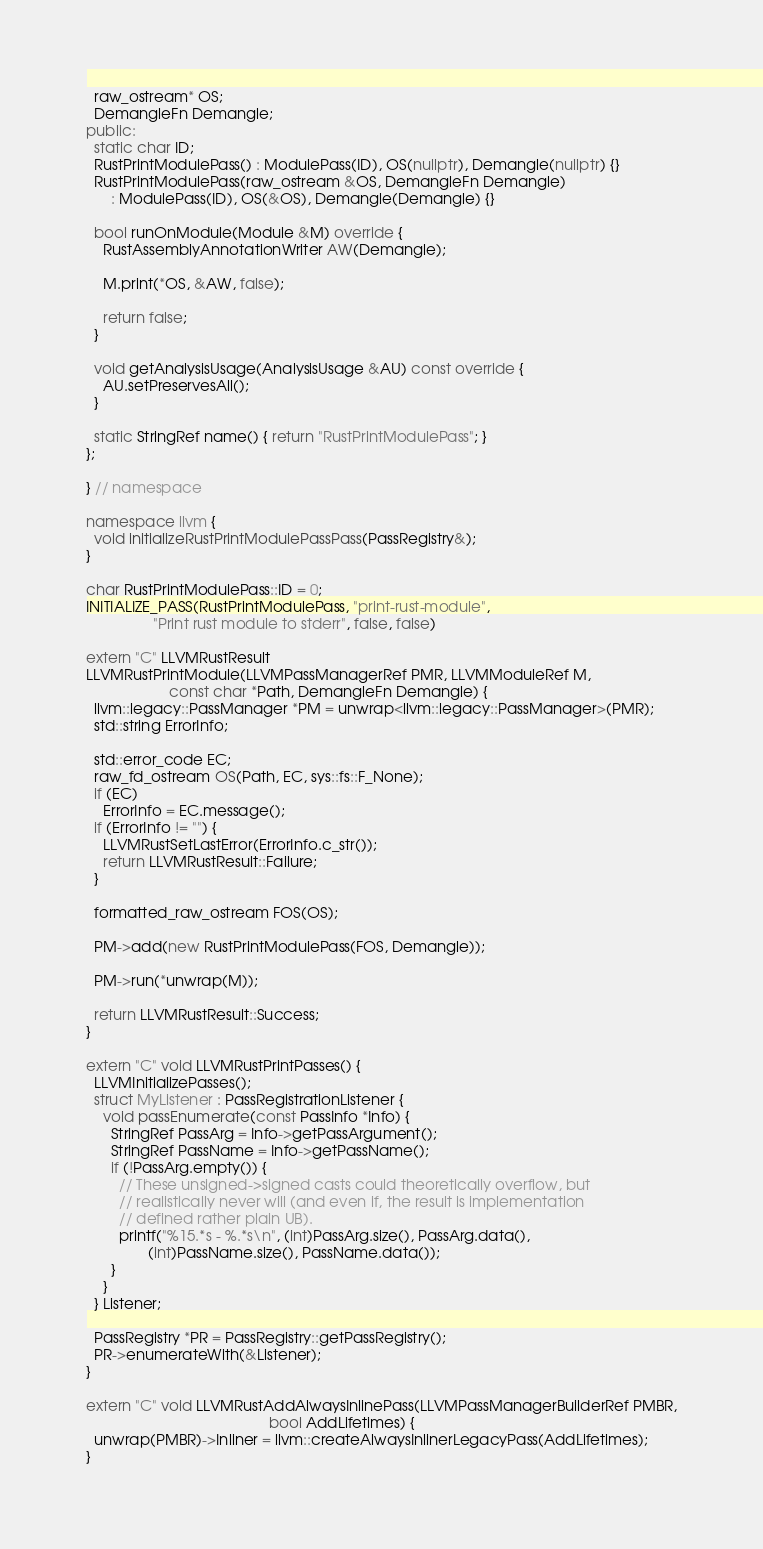Convert code to text. <code><loc_0><loc_0><loc_500><loc_500><_C++_>  raw_ostream* OS;
  DemangleFn Demangle;
public:
  static char ID;
  RustPrintModulePass() : ModulePass(ID), OS(nullptr), Demangle(nullptr) {}
  RustPrintModulePass(raw_ostream &OS, DemangleFn Demangle)
      : ModulePass(ID), OS(&OS), Demangle(Demangle) {}

  bool runOnModule(Module &M) override {
    RustAssemblyAnnotationWriter AW(Demangle);

    M.print(*OS, &AW, false);

    return false;
  }

  void getAnalysisUsage(AnalysisUsage &AU) const override {
    AU.setPreservesAll();
  }

  static StringRef name() { return "RustPrintModulePass"; }
};

} // namespace

namespace llvm {
  void initializeRustPrintModulePassPass(PassRegistry&);
}

char RustPrintModulePass::ID = 0;
INITIALIZE_PASS(RustPrintModulePass, "print-rust-module",
                "Print rust module to stderr", false, false)

extern "C" LLVMRustResult
LLVMRustPrintModule(LLVMPassManagerRef PMR, LLVMModuleRef M,
                    const char *Path, DemangleFn Demangle) {
  llvm::legacy::PassManager *PM = unwrap<llvm::legacy::PassManager>(PMR);
  std::string ErrorInfo;

  std::error_code EC;
  raw_fd_ostream OS(Path, EC, sys::fs::F_None);
  if (EC)
    ErrorInfo = EC.message();
  if (ErrorInfo != "") {
    LLVMRustSetLastError(ErrorInfo.c_str());
    return LLVMRustResult::Failure;
  }

  formatted_raw_ostream FOS(OS);

  PM->add(new RustPrintModulePass(FOS, Demangle));

  PM->run(*unwrap(M));

  return LLVMRustResult::Success;
}

extern "C" void LLVMRustPrintPasses() {
  LLVMInitializePasses();
  struct MyListener : PassRegistrationListener {
    void passEnumerate(const PassInfo *Info) {
      StringRef PassArg = Info->getPassArgument();
      StringRef PassName = Info->getPassName();
      if (!PassArg.empty()) {
        // These unsigned->signed casts could theoretically overflow, but
        // realistically never will (and even if, the result is implementation
        // defined rather plain UB).
        printf("%15.*s - %.*s\n", (int)PassArg.size(), PassArg.data(),
               (int)PassName.size(), PassName.data());
      }
    }
  } Listener;

  PassRegistry *PR = PassRegistry::getPassRegistry();
  PR->enumerateWith(&Listener);
}

extern "C" void LLVMRustAddAlwaysInlinePass(LLVMPassManagerBuilderRef PMBR,
                                            bool AddLifetimes) {
  unwrap(PMBR)->Inliner = llvm::createAlwaysInlinerLegacyPass(AddLifetimes);
}
</code> 